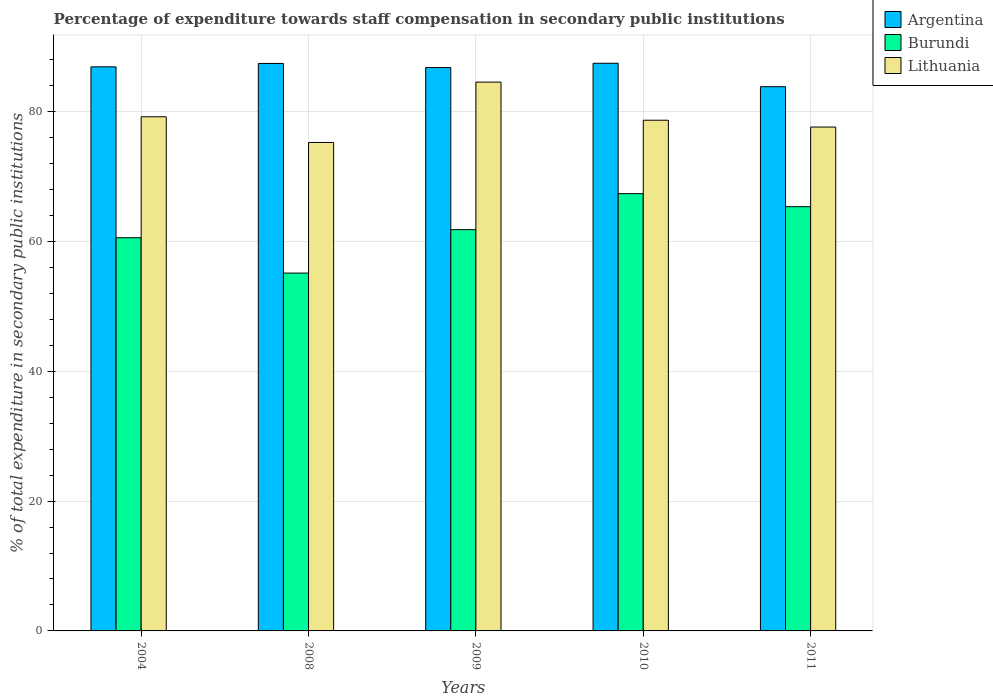How many groups of bars are there?
Give a very brief answer. 5. Are the number of bars per tick equal to the number of legend labels?
Offer a very short reply. Yes. Are the number of bars on each tick of the X-axis equal?
Offer a very short reply. Yes. How many bars are there on the 1st tick from the right?
Provide a short and direct response. 3. What is the label of the 5th group of bars from the left?
Your answer should be very brief. 2011. What is the percentage of expenditure towards staff compensation in Burundi in 2009?
Offer a very short reply. 61.82. Across all years, what is the maximum percentage of expenditure towards staff compensation in Argentina?
Ensure brevity in your answer.  87.45. Across all years, what is the minimum percentage of expenditure towards staff compensation in Burundi?
Provide a short and direct response. 55.13. In which year was the percentage of expenditure towards staff compensation in Lithuania minimum?
Your response must be concise. 2008. What is the total percentage of expenditure towards staff compensation in Argentina in the graph?
Ensure brevity in your answer.  432.41. What is the difference between the percentage of expenditure towards staff compensation in Burundi in 2010 and that in 2011?
Your response must be concise. 2.01. What is the difference between the percentage of expenditure towards staff compensation in Argentina in 2011 and the percentage of expenditure towards staff compensation in Lithuania in 2010?
Your response must be concise. 5.17. What is the average percentage of expenditure towards staff compensation in Burundi per year?
Provide a short and direct response. 62.05. In the year 2010, what is the difference between the percentage of expenditure towards staff compensation in Burundi and percentage of expenditure towards staff compensation in Argentina?
Your answer should be compact. -20.09. What is the ratio of the percentage of expenditure towards staff compensation in Lithuania in 2009 to that in 2010?
Provide a succinct answer. 1.07. Is the percentage of expenditure towards staff compensation in Argentina in 2008 less than that in 2011?
Offer a very short reply. No. What is the difference between the highest and the second highest percentage of expenditure towards staff compensation in Argentina?
Ensure brevity in your answer.  0.03. What is the difference between the highest and the lowest percentage of expenditure towards staff compensation in Lithuania?
Your answer should be compact. 9.3. In how many years, is the percentage of expenditure towards staff compensation in Burundi greater than the average percentage of expenditure towards staff compensation in Burundi taken over all years?
Ensure brevity in your answer.  2. What does the 2nd bar from the left in 2011 represents?
Offer a very short reply. Burundi. What does the 2nd bar from the right in 2011 represents?
Your answer should be very brief. Burundi. Is it the case that in every year, the sum of the percentage of expenditure towards staff compensation in Burundi and percentage of expenditure towards staff compensation in Argentina is greater than the percentage of expenditure towards staff compensation in Lithuania?
Your response must be concise. Yes. Are the values on the major ticks of Y-axis written in scientific E-notation?
Your answer should be compact. No. Does the graph contain any zero values?
Ensure brevity in your answer.  No. Does the graph contain grids?
Ensure brevity in your answer.  Yes. How many legend labels are there?
Make the answer very short. 3. How are the legend labels stacked?
Provide a short and direct response. Vertical. What is the title of the graph?
Ensure brevity in your answer.  Percentage of expenditure towards staff compensation in secondary public institutions. What is the label or title of the X-axis?
Give a very brief answer. Years. What is the label or title of the Y-axis?
Your response must be concise. % of total expenditure in secondary public institutions. What is the % of total expenditure in secondary public institutions of Argentina in 2004?
Offer a terse response. 86.9. What is the % of total expenditure in secondary public institutions in Burundi in 2004?
Make the answer very short. 60.57. What is the % of total expenditure in secondary public institutions of Lithuania in 2004?
Your response must be concise. 79.21. What is the % of total expenditure in secondary public institutions in Argentina in 2008?
Your answer should be compact. 87.43. What is the % of total expenditure in secondary public institutions of Burundi in 2008?
Ensure brevity in your answer.  55.13. What is the % of total expenditure in secondary public institutions in Lithuania in 2008?
Your answer should be very brief. 75.25. What is the % of total expenditure in secondary public institutions in Argentina in 2009?
Ensure brevity in your answer.  86.79. What is the % of total expenditure in secondary public institutions of Burundi in 2009?
Your answer should be very brief. 61.82. What is the % of total expenditure in secondary public institutions of Lithuania in 2009?
Offer a terse response. 84.55. What is the % of total expenditure in secondary public institutions in Argentina in 2010?
Ensure brevity in your answer.  87.45. What is the % of total expenditure in secondary public institutions of Burundi in 2010?
Offer a terse response. 67.37. What is the % of total expenditure in secondary public institutions of Lithuania in 2010?
Your response must be concise. 78.68. What is the % of total expenditure in secondary public institutions in Argentina in 2011?
Provide a short and direct response. 83.84. What is the % of total expenditure in secondary public institutions in Burundi in 2011?
Make the answer very short. 65.36. What is the % of total expenditure in secondary public institutions of Lithuania in 2011?
Provide a short and direct response. 77.63. Across all years, what is the maximum % of total expenditure in secondary public institutions of Argentina?
Provide a short and direct response. 87.45. Across all years, what is the maximum % of total expenditure in secondary public institutions of Burundi?
Ensure brevity in your answer.  67.37. Across all years, what is the maximum % of total expenditure in secondary public institutions of Lithuania?
Your answer should be very brief. 84.55. Across all years, what is the minimum % of total expenditure in secondary public institutions of Argentina?
Make the answer very short. 83.84. Across all years, what is the minimum % of total expenditure in secondary public institutions of Burundi?
Offer a terse response. 55.13. Across all years, what is the minimum % of total expenditure in secondary public institutions in Lithuania?
Provide a succinct answer. 75.25. What is the total % of total expenditure in secondary public institutions of Argentina in the graph?
Offer a very short reply. 432.41. What is the total % of total expenditure in secondary public institutions of Burundi in the graph?
Your response must be concise. 310.24. What is the total % of total expenditure in secondary public institutions of Lithuania in the graph?
Your answer should be compact. 395.31. What is the difference between the % of total expenditure in secondary public institutions of Argentina in 2004 and that in 2008?
Provide a succinct answer. -0.53. What is the difference between the % of total expenditure in secondary public institutions in Burundi in 2004 and that in 2008?
Ensure brevity in your answer.  5.44. What is the difference between the % of total expenditure in secondary public institutions in Lithuania in 2004 and that in 2008?
Provide a succinct answer. 3.96. What is the difference between the % of total expenditure in secondary public institutions in Argentina in 2004 and that in 2009?
Keep it short and to the point. 0.11. What is the difference between the % of total expenditure in secondary public institutions of Burundi in 2004 and that in 2009?
Provide a short and direct response. -1.24. What is the difference between the % of total expenditure in secondary public institutions of Lithuania in 2004 and that in 2009?
Offer a very short reply. -5.34. What is the difference between the % of total expenditure in secondary public institutions of Argentina in 2004 and that in 2010?
Your answer should be compact. -0.55. What is the difference between the % of total expenditure in secondary public institutions of Burundi in 2004 and that in 2010?
Your answer should be compact. -6.79. What is the difference between the % of total expenditure in secondary public institutions of Lithuania in 2004 and that in 2010?
Offer a very short reply. 0.53. What is the difference between the % of total expenditure in secondary public institutions of Argentina in 2004 and that in 2011?
Provide a succinct answer. 3.06. What is the difference between the % of total expenditure in secondary public institutions of Burundi in 2004 and that in 2011?
Your answer should be very brief. -4.78. What is the difference between the % of total expenditure in secondary public institutions in Lithuania in 2004 and that in 2011?
Ensure brevity in your answer.  1.58. What is the difference between the % of total expenditure in secondary public institutions of Argentina in 2008 and that in 2009?
Make the answer very short. 0.64. What is the difference between the % of total expenditure in secondary public institutions of Burundi in 2008 and that in 2009?
Ensure brevity in your answer.  -6.69. What is the difference between the % of total expenditure in secondary public institutions of Lithuania in 2008 and that in 2009?
Your response must be concise. -9.3. What is the difference between the % of total expenditure in secondary public institutions in Argentina in 2008 and that in 2010?
Your answer should be compact. -0.03. What is the difference between the % of total expenditure in secondary public institutions of Burundi in 2008 and that in 2010?
Provide a succinct answer. -12.24. What is the difference between the % of total expenditure in secondary public institutions in Lithuania in 2008 and that in 2010?
Provide a succinct answer. -3.43. What is the difference between the % of total expenditure in secondary public institutions of Argentina in 2008 and that in 2011?
Your answer should be very brief. 3.58. What is the difference between the % of total expenditure in secondary public institutions in Burundi in 2008 and that in 2011?
Make the answer very short. -10.23. What is the difference between the % of total expenditure in secondary public institutions in Lithuania in 2008 and that in 2011?
Provide a short and direct response. -2.38. What is the difference between the % of total expenditure in secondary public institutions of Argentina in 2009 and that in 2010?
Give a very brief answer. -0.66. What is the difference between the % of total expenditure in secondary public institutions in Burundi in 2009 and that in 2010?
Ensure brevity in your answer.  -5.55. What is the difference between the % of total expenditure in secondary public institutions in Lithuania in 2009 and that in 2010?
Offer a terse response. 5.87. What is the difference between the % of total expenditure in secondary public institutions of Argentina in 2009 and that in 2011?
Ensure brevity in your answer.  2.95. What is the difference between the % of total expenditure in secondary public institutions in Burundi in 2009 and that in 2011?
Provide a succinct answer. -3.54. What is the difference between the % of total expenditure in secondary public institutions of Lithuania in 2009 and that in 2011?
Your answer should be compact. 6.92. What is the difference between the % of total expenditure in secondary public institutions of Argentina in 2010 and that in 2011?
Offer a terse response. 3.61. What is the difference between the % of total expenditure in secondary public institutions of Burundi in 2010 and that in 2011?
Offer a terse response. 2.01. What is the difference between the % of total expenditure in secondary public institutions in Lithuania in 2010 and that in 2011?
Make the answer very short. 1.05. What is the difference between the % of total expenditure in secondary public institutions of Argentina in 2004 and the % of total expenditure in secondary public institutions of Burundi in 2008?
Keep it short and to the point. 31.77. What is the difference between the % of total expenditure in secondary public institutions of Argentina in 2004 and the % of total expenditure in secondary public institutions of Lithuania in 2008?
Provide a succinct answer. 11.65. What is the difference between the % of total expenditure in secondary public institutions in Burundi in 2004 and the % of total expenditure in secondary public institutions in Lithuania in 2008?
Provide a succinct answer. -14.68. What is the difference between the % of total expenditure in secondary public institutions in Argentina in 2004 and the % of total expenditure in secondary public institutions in Burundi in 2009?
Offer a very short reply. 25.08. What is the difference between the % of total expenditure in secondary public institutions of Argentina in 2004 and the % of total expenditure in secondary public institutions of Lithuania in 2009?
Provide a succinct answer. 2.35. What is the difference between the % of total expenditure in secondary public institutions of Burundi in 2004 and the % of total expenditure in secondary public institutions of Lithuania in 2009?
Ensure brevity in your answer.  -23.98. What is the difference between the % of total expenditure in secondary public institutions in Argentina in 2004 and the % of total expenditure in secondary public institutions in Burundi in 2010?
Provide a short and direct response. 19.53. What is the difference between the % of total expenditure in secondary public institutions in Argentina in 2004 and the % of total expenditure in secondary public institutions in Lithuania in 2010?
Your answer should be very brief. 8.22. What is the difference between the % of total expenditure in secondary public institutions in Burundi in 2004 and the % of total expenditure in secondary public institutions in Lithuania in 2010?
Give a very brief answer. -18.1. What is the difference between the % of total expenditure in secondary public institutions in Argentina in 2004 and the % of total expenditure in secondary public institutions in Burundi in 2011?
Your answer should be compact. 21.54. What is the difference between the % of total expenditure in secondary public institutions in Argentina in 2004 and the % of total expenditure in secondary public institutions in Lithuania in 2011?
Your response must be concise. 9.27. What is the difference between the % of total expenditure in secondary public institutions in Burundi in 2004 and the % of total expenditure in secondary public institutions in Lithuania in 2011?
Offer a terse response. -17.05. What is the difference between the % of total expenditure in secondary public institutions of Argentina in 2008 and the % of total expenditure in secondary public institutions of Burundi in 2009?
Provide a short and direct response. 25.61. What is the difference between the % of total expenditure in secondary public institutions of Argentina in 2008 and the % of total expenditure in secondary public institutions of Lithuania in 2009?
Give a very brief answer. 2.88. What is the difference between the % of total expenditure in secondary public institutions in Burundi in 2008 and the % of total expenditure in secondary public institutions in Lithuania in 2009?
Your response must be concise. -29.42. What is the difference between the % of total expenditure in secondary public institutions of Argentina in 2008 and the % of total expenditure in secondary public institutions of Burundi in 2010?
Provide a short and direct response. 20.06. What is the difference between the % of total expenditure in secondary public institutions of Argentina in 2008 and the % of total expenditure in secondary public institutions of Lithuania in 2010?
Your answer should be compact. 8.75. What is the difference between the % of total expenditure in secondary public institutions of Burundi in 2008 and the % of total expenditure in secondary public institutions of Lithuania in 2010?
Provide a short and direct response. -23.55. What is the difference between the % of total expenditure in secondary public institutions of Argentina in 2008 and the % of total expenditure in secondary public institutions of Burundi in 2011?
Make the answer very short. 22.07. What is the difference between the % of total expenditure in secondary public institutions in Argentina in 2008 and the % of total expenditure in secondary public institutions in Lithuania in 2011?
Give a very brief answer. 9.8. What is the difference between the % of total expenditure in secondary public institutions in Burundi in 2008 and the % of total expenditure in secondary public institutions in Lithuania in 2011?
Offer a terse response. -22.5. What is the difference between the % of total expenditure in secondary public institutions in Argentina in 2009 and the % of total expenditure in secondary public institutions in Burundi in 2010?
Ensure brevity in your answer.  19.42. What is the difference between the % of total expenditure in secondary public institutions of Argentina in 2009 and the % of total expenditure in secondary public institutions of Lithuania in 2010?
Your answer should be very brief. 8.11. What is the difference between the % of total expenditure in secondary public institutions in Burundi in 2009 and the % of total expenditure in secondary public institutions in Lithuania in 2010?
Give a very brief answer. -16.86. What is the difference between the % of total expenditure in secondary public institutions in Argentina in 2009 and the % of total expenditure in secondary public institutions in Burundi in 2011?
Your response must be concise. 21.43. What is the difference between the % of total expenditure in secondary public institutions in Argentina in 2009 and the % of total expenditure in secondary public institutions in Lithuania in 2011?
Your answer should be compact. 9.16. What is the difference between the % of total expenditure in secondary public institutions in Burundi in 2009 and the % of total expenditure in secondary public institutions in Lithuania in 2011?
Ensure brevity in your answer.  -15.81. What is the difference between the % of total expenditure in secondary public institutions of Argentina in 2010 and the % of total expenditure in secondary public institutions of Burundi in 2011?
Your response must be concise. 22.1. What is the difference between the % of total expenditure in secondary public institutions of Argentina in 2010 and the % of total expenditure in secondary public institutions of Lithuania in 2011?
Your answer should be very brief. 9.83. What is the difference between the % of total expenditure in secondary public institutions in Burundi in 2010 and the % of total expenditure in secondary public institutions in Lithuania in 2011?
Your response must be concise. -10.26. What is the average % of total expenditure in secondary public institutions in Argentina per year?
Offer a very short reply. 86.48. What is the average % of total expenditure in secondary public institutions of Burundi per year?
Make the answer very short. 62.05. What is the average % of total expenditure in secondary public institutions in Lithuania per year?
Give a very brief answer. 79.06. In the year 2004, what is the difference between the % of total expenditure in secondary public institutions of Argentina and % of total expenditure in secondary public institutions of Burundi?
Make the answer very short. 26.33. In the year 2004, what is the difference between the % of total expenditure in secondary public institutions of Argentina and % of total expenditure in secondary public institutions of Lithuania?
Give a very brief answer. 7.69. In the year 2004, what is the difference between the % of total expenditure in secondary public institutions of Burundi and % of total expenditure in secondary public institutions of Lithuania?
Offer a very short reply. -18.64. In the year 2008, what is the difference between the % of total expenditure in secondary public institutions of Argentina and % of total expenditure in secondary public institutions of Burundi?
Ensure brevity in your answer.  32.3. In the year 2008, what is the difference between the % of total expenditure in secondary public institutions of Argentina and % of total expenditure in secondary public institutions of Lithuania?
Make the answer very short. 12.18. In the year 2008, what is the difference between the % of total expenditure in secondary public institutions in Burundi and % of total expenditure in secondary public institutions in Lithuania?
Provide a succinct answer. -20.12. In the year 2009, what is the difference between the % of total expenditure in secondary public institutions of Argentina and % of total expenditure in secondary public institutions of Burundi?
Offer a terse response. 24.97. In the year 2009, what is the difference between the % of total expenditure in secondary public institutions of Argentina and % of total expenditure in secondary public institutions of Lithuania?
Give a very brief answer. 2.24. In the year 2009, what is the difference between the % of total expenditure in secondary public institutions in Burundi and % of total expenditure in secondary public institutions in Lithuania?
Make the answer very short. -22.73. In the year 2010, what is the difference between the % of total expenditure in secondary public institutions in Argentina and % of total expenditure in secondary public institutions in Burundi?
Give a very brief answer. 20.09. In the year 2010, what is the difference between the % of total expenditure in secondary public institutions in Argentina and % of total expenditure in secondary public institutions in Lithuania?
Ensure brevity in your answer.  8.78. In the year 2010, what is the difference between the % of total expenditure in secondary public institutions in Burundi and % of total expenditure in secondary public institutions in Lithuania?
Provide a succinct answer. -11.31. In the year 2011, what is the difference between the % of total expenditure in secondary public institutions in Argentina and % of total expenditure in secondary public institutions in Burundi?
Offer a terse response. 18.49. In the year 2011, what is the difference between the % of total expenditure in secondary public institutions of Argentina and % of total expenditure in secondary public institutions of Lithuania?
Give a very brief answer. 6.21. In the year 2011, what is the difference between the % of total expenditure in secondary public institutions in Burundi and % of total expenditure in secondary public institutions in Lithuania?
Your answer should be very brief. -12.27. What is the ratio of the % of total expenditure in secondary public institutions of Argentina in 2004 to that in 2008?
Your response must be concise. 0.99. What is the ratio of the % of total expenditure in secondary public institutions of Burundi in 2004 to that in 2008?
Ensure brevity in your answer.  1.1. What is the ratio of the % of total expenditure in secondary public institutions in Lithuania in 2004 to that in 2008?
Offer a very short reply. 1.05. What is the ratio of the % of total expenditure in secondary public institutions of Argentina in 2004 to that in 2009?
Your answer should be very brief. 1. What is the ratio of the % of total expenditure in secondary public institutions of Burundi in 2004 to that in 2009?
Give a very brief answer. 0.98. What is the ratio of the % of total expenditure in secondary public institutions in Lithuania in 2004 to that in 2009?
Ensure brevity in your answer.  0.94. What is the ratio of the % of total expenditure in secondary public institutions in Burundi in 2004 to that in 2010?
Offer a terse response. 0.9. What is the ratio of the % of total expenditure in secondary public institutions of Lithuania in 2004 to that in 2010?
Your response must be concise. 1.01. What is the ratio of the % of total expenditure in secondary public institutions in Argentina in 2004 to that in 2011?
Provide a short and direct response. 1.04. What is the ratio of the % of total expenditure in secondary public institutions in Burundi in 2004 to that in 2011?
Your answer should be compact. 0.93. What is the ratio of the % of total expenditure in secondary public institutions in Lithuania in 2004 to that in 2011?
Offer a very short reply. 1.02. What is the ratio of the % of total expenditure in secondary public institutions of Argentina in 2008 to that in 2009?
Offer a terse response. 1.01. What is the ratio of the % of total expenditure in secondary public institutions of Burundi in 2008 to that in 2009?
Your answer should be very brief. 0.89. What is the ratio of the % of total expenditure in secondary public institutions of Lithuania in 2008 to that in 2009?
Offer a terse response. 0.89. What is the ratio of the % of total expenditure in secondary public institutions in Argentina in 2008 to that in 2010?
Your answer should be compact. 1. What is the ratio of the % of total expenditure in secondary public institutions of Burundi in 2008 to that in 2010?
Provide a short and direct response. 0.82. What is the ratio of the % of total expenditure in secondary public institutions of Lithuania in 2008 to that in 2010?
Ensure brevity in your answer.  0.96. What is the ratio of the % of total expenditure in secondary public institutions in Argentina in 2008 to that in 2011?
Offer a terse response. 1.04. What is the ratio of the % of total expenditure in secondary public institutions in Burundi in 2008 to that in 2011?
Provide a succinct answer. 0.84. What is the ratio of the % of total expenditure in secondary public institutions in Lithuania in 2008 to that in 2011?
Your answer should be very brief. 0.97. What is the ratio of the % of total expenditure in secondary public institutions in Argentina in 2009 to that in 2010?
Make the answer very short. 0.99. What is the ratio of the % of total expenditure in secondary public institutions of Burundi in 2009 to that in 2010?
Offer a terse response. 0.92. What is the ratio of the % of total expenditure in secondary public institutions in Lithuania in 2009 to that in 2010?
Offer a terse response. 1.07. What is the ratio of the % of total expenditure in secondary public institutions of Argentina in 2009 to that in 2011?
Ensure brevity in your answer.  1.04. What is the ratio of the % of total expenditure in secondary public institutions of Burundi in 2009 to that in 2011?
Offer a very short reply. 0.95. What is the ratio of the % of total expenditure in secondary public institutions in Lithuania in 2009 to that in 2011?
Provide a short and direct response. 1.09. What is the ratio of the % of total expenditure in secondary public institutions in Argentina in 2010 to that in 2011?
Provide a succinct answer. 1.04. What is the ratio of the % of total expenditure in secondary public institutions of Burundi in 2010 to that in 2011?
Your response must be concise. 1.03. What is the ratio of the % of total expenditure in secondary public institutions of Lithuania in 2010 to that in 2011?
Your response must be concise. 1.01. What is the difference between the highest and the second highest % of total expenditure in secondary public institutions of Argentina?
Offer a very short reply. 0.03. What is the difference between the highest and the second highest % of total expenditure in secondary public institutions in Burundi?
Provide a short and direct response. 2.01. What is the difference between the highest and the second highest % of total expenditure in secondary public institutions in Lithuania?
Your response must be concise. 5.34. What is the difference between the highest and the lowest % of total expenditure in secondary public institutions of Argentina?
Provide a short and direct response. 3.61. What is the difference between the highest and the lowest % of total expenditure in secondary public institutions in Burundi?
Offer a terse response. 12.24. What is the difference between the highest and the lowest % of total expenditure in secondary public institutions in Lithuania?
Offer a very short reply. 9.3. 